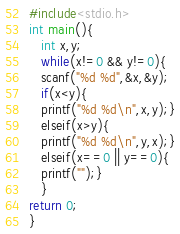Convert code to text. <code><loc_0><loc_0><loc_500><loc_500><_C_>#include<stdio.h>
int main(){
   int x,y;
   while(x!=0 && y!=0){
   scanf("%d %d",&x,&y);
   if(x<y){
   printf("%d %d\n",x,y);}
   elseif(x>y){
   printf("%d %d\n",y,x);}
   elseif(x==0 || y==0){
   printf("");}
   }
return 0;
}</code> 